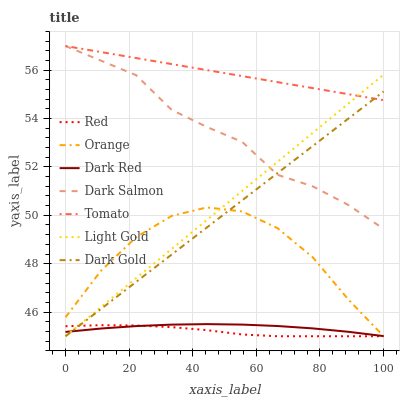Does Red have the minimum area under the curve?
Answer yes or no. Yes. Does Tomato have the maximum area under the curve?
Answer yes or no. Yes. Does Dark Gold have the minimum area under the curve?
Answer yes or no. No. Does Dark Gold have the maximum area under the curve?
Answer yes or no. No. Is Dark Gold the smoothest?
Answer yes or no. Yes. Is Orange the roughest?
Answer yes or no. Yes. Is Dark Red the smoothest?
Answer yes or no. No. Is Dark Red the roughest?
Answer yes or no. No. Does Dark Gold have the lowest value?
Answer yes or no. Yes. Does Dark Red have the lowest value?
Answer yes or no. No. Does Dark Salmon have the highest value?
Answer yes or no. Yes. Does Dark Gold have the highest value?
Answer yes or no. No. Is Orange less than Tomato?
Answer yes or no. Yes. Is Tomato greater than Red?
Answer yes or no. Yes. Does Dark Salmon intersect Light Gold?
Answer yes or no. Yes. Is Dark Salmon less than Light Gold?
Answer yes or no. No. Is Dark Salmon greater than Light Gold?
Answer yes or no. No. Does Orange intersect Tomato?
Answer yes or no. No. 